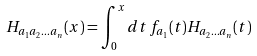Convert formula to latex. <formula><loc_0><loc_0><loc_500><loc_500>H _ { a _ { 1 } a _ { 2 } \dots a _ { n } } ( x ) = \int _ { 0 } ^ { x } d t \, f _ { a _ { 1 } } ( t ) H _ { a _ { 2 } \dots a _ { n } } ( t )</formula> 